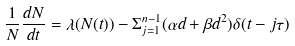<formula> <loc_0><loc_0><loc_500><loc_500>\frac { 1 } { N } \frac { d N } { d t } = \lambda ( N ( t ) ) - \Sigma _ { j = 1 } ^ { n - 1 } ( \alpha d + \beta d ^ { 2 } ) \delta ( t - j \tau )</formula> 